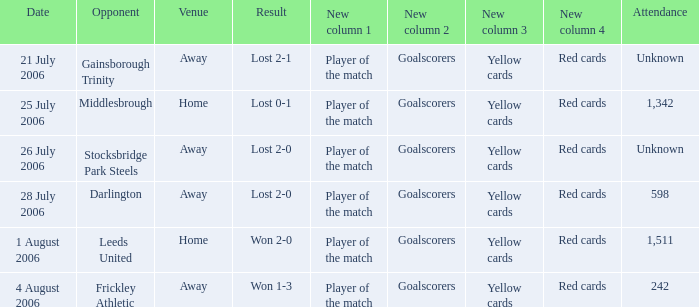Could you parse the entire table? {'header': ['Date', 'Opponent', 'Venue', 'Result', 'New column 1', 'New column 2', 'New column 3', 'New column 4', 'Attendance'], 'rows': [['21 July 2006', 'Gainsborough Trinity', 'Away', 'Lost 2-1', 'Player of the match', 'Goalscorers', 'Yellow cards', 'Red cards', 'Unknown'], ['25 July 2006', 'Middlesbrough', 'Home', 'Lost 0-1', 'Player of the match', 'Goalscorers', 'Yellow cards', 'Red cards', '1,342'], ['26 July 2006', 'Stocksbridge Park Steels', 'Away', 'Lost 2-0', 'Player of the match', 'Goalscorers', 'Yellow cards', 'Red cards', 'Unknown'], ['28 July 2006', 'Darlington', 'Away', 'Lost 2-0', 'Player of the match', 'Goalscorers', 'Yellow cards', 'Red cards', '598'], ['1 August 2006', 'Leeds United', 'Home', 'Won 2-0', 'Player of the match', 'Goalscorers', 'Yellow cards', 'Red cards', '1,511'], ['4 August 2006', 'Frickley Athletic', 'Away', 'Won 1-3', 'Player of the match', 'Goalscorers', 'Yellow cards', 'Red cards', '242']]} Which opponent has unknown attendance, and lost 2-0? Stocksbridge Park Steels. 